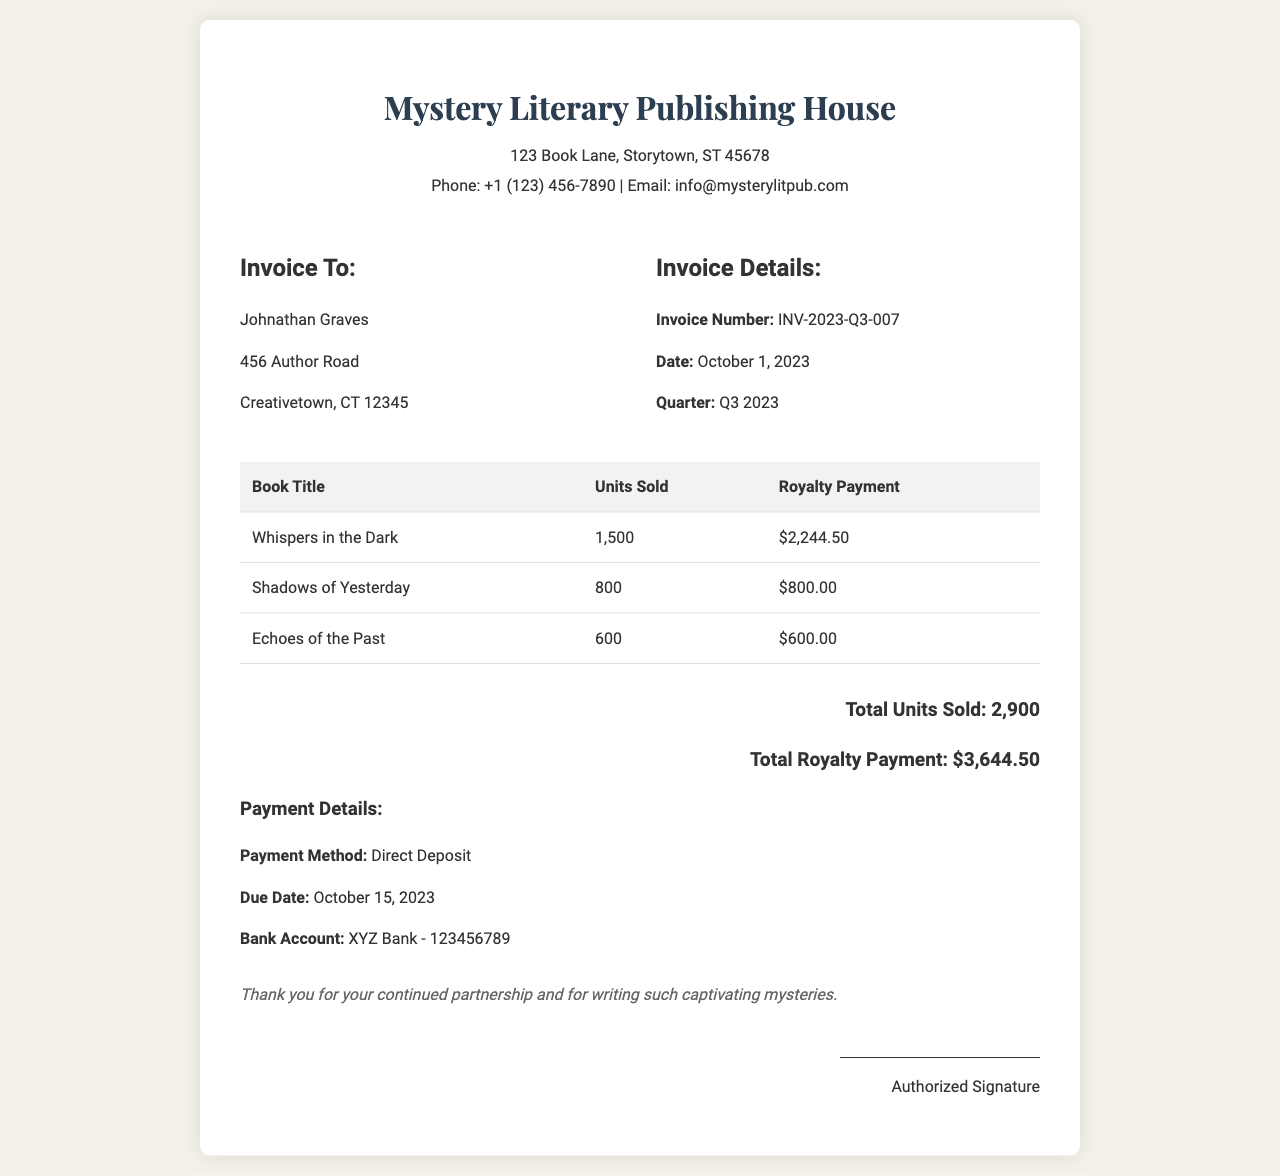What is the invoice number? The invoice number can be found in the Invoice Details section, labeled as "Invoice Number."
Answer: INV-2023-Q3-007 What is the due date for the payment? The due date is specified in the Payment Details section, under "Due Date."
Answer: October 15, 2023 How many units of "Whispers in the Dark" were sold? The number of units sold for each book is listed in the table under "Units Sold" corresponding to "Whispers in the Dark."
Answer: 1,500 What is the total royalty payment? The total royalty payment is mentioned at the end of the invoice, summing all individual payments.
Answer: $3,644.50 What is the name of the author? The author's name is provided at the top of the invoice in the "Invoice To" section.
Answer: Johnathan Graves How many total units were sold in Q3 2023? The total units sold can be calculated from the sums of the "Units Sold" column in the table.
Answer: 2,900 What is the payment method? The payment method is indicated in the Payment Details section under "Payment Method."
Answer: Direct Deposit What bank account number is listed for the payment? The bank account number is specified in the Payment Details section.
Answer: 123456789 